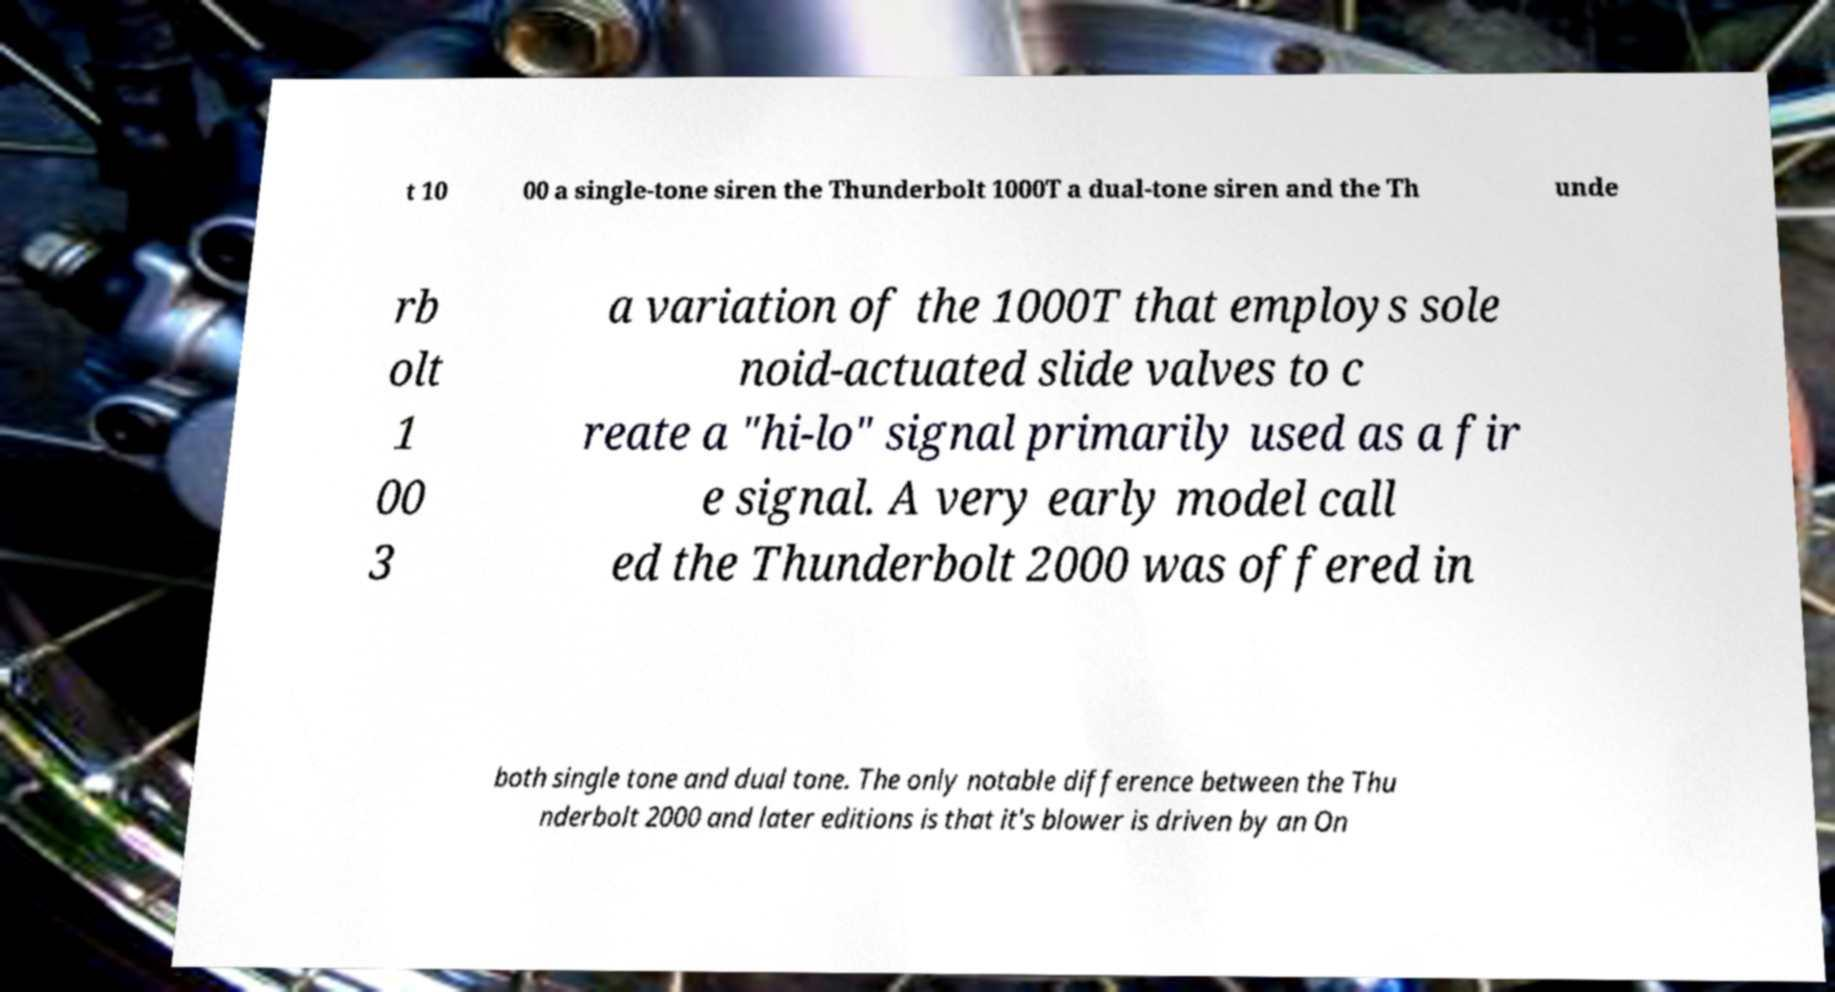For documentation purposes, I need the text within this image transcribed. Could you provide that? t 10 00 a single-tone siren the Thunderbolt 1000T a dual-tone siren and the Th unde rb olt 1 00 3 a variation of the 1000T that employs sole noid-actuated slide valves to c reate a "hi-lo" signal primarily used as a fir e signal. A very early model call ed the Thunderbolt 2000 was offered in both single tone and dual tone. The only notable difference between the Thu nderbolt 2000 and later editions is that it's blower is driven by an On 